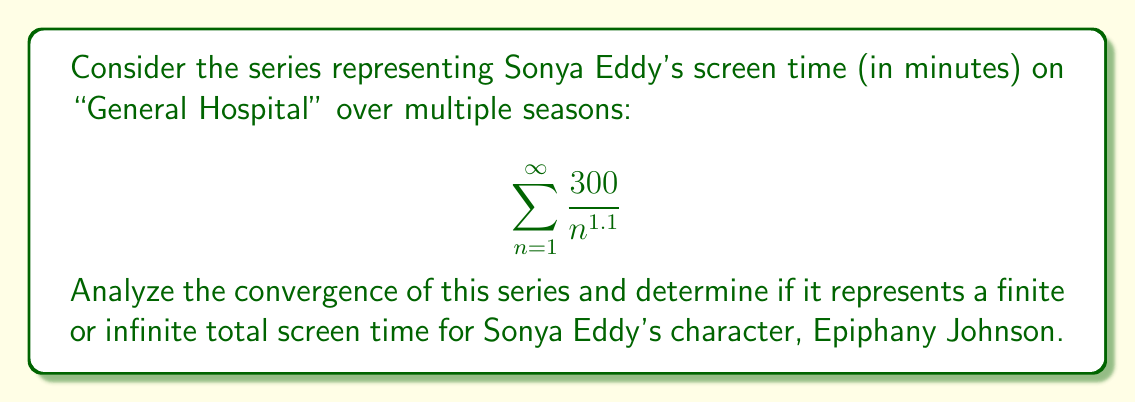What is the answer to this math problem? To analyze the convergence of this series, we'll use the p-series test:

1) The general form of a p-series is $\sum_{n=1}^{\infty} \frac{1}{n^p}$

2) Our series can be rewritten as:

   $$\sum_{n=1}^{\infty} \frac{300}{n^{1.1}} = 300 \sum_{n=1}^{\infty} \frac{1}{n^{1.1}}$$

3) In this case, $p = 1.1$

4) The p-series convergence theorem states:
   - If $p > 1$, the series converges
   - If $p \leq 1$, the series diverges

5) Since $1.1 > 1$, our series converges.

6) To interpret this result:
   - Convergence means the sum of the series approaches a finite value
   - This implies that Sonya Eddy's total screen time over all seasons is finite
   - The series converges to some value $S$, where $S = 300 \cdot \zeta(1.1)$
     and $\zeta$ is the Riemann zeta function

7) We can estimate this value:
   $\zeta(1.1) \approx 10.584$
   $S \approx 300 \cdot 10.584 = 3175.2$ minutes

This means Sonya Eddy's character would have approximately 3175.2 minutes (about 53 hours) of total screen time across all seasons, assuming this model accurately represents her appearances.
Answer: The series $\sum_{n=1}^{\infty} \frac{300}{n^{1.1}}$ converges, representing a finite total screen time for Sonya Eddy's character. The estimated total screen time is approximately 3175.2 minutes. 